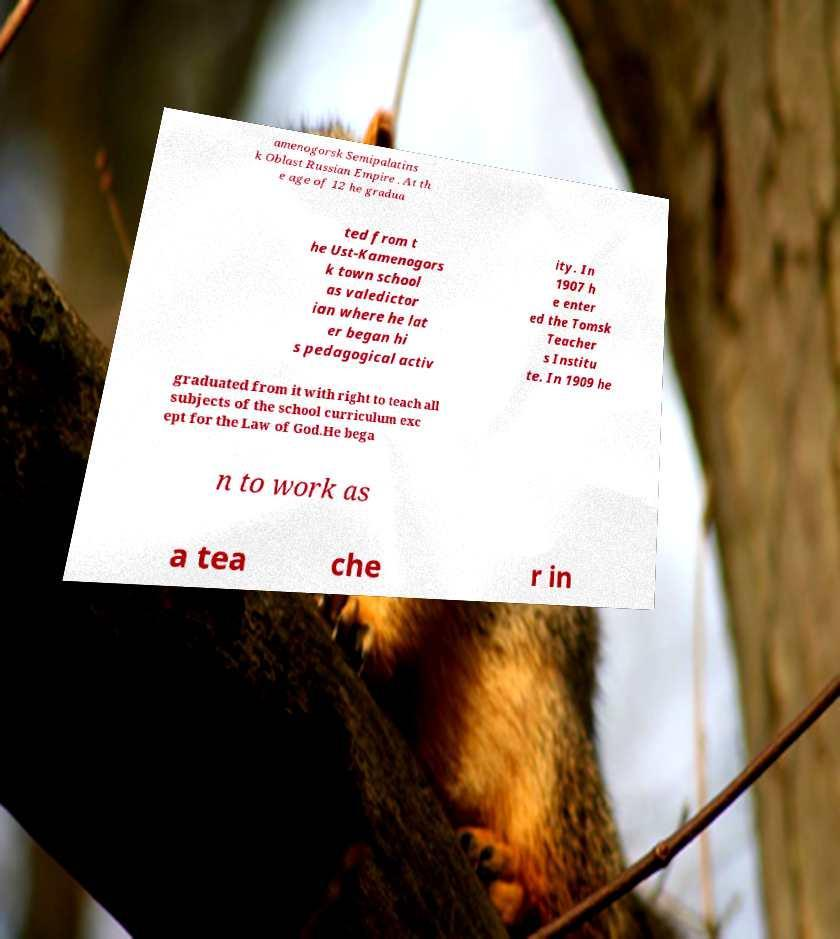What messages or text are displayed in this image? I need them in a readable, typed format. amenogorsk Semipalatins k Oblast Russian Empire . At th e age of 12 he gradua ted from t he Ust-Kamenogors k town school as valedictor ian where he lat er began hi s pedagogical activ ity. In 1907 h e enter ed the Tomsk Teacher s Institu te. In 1909 he graduated from it with right to teach all subjects of the school curriculum exc ept for the Law of God.He bega n to work as a tea che r in 